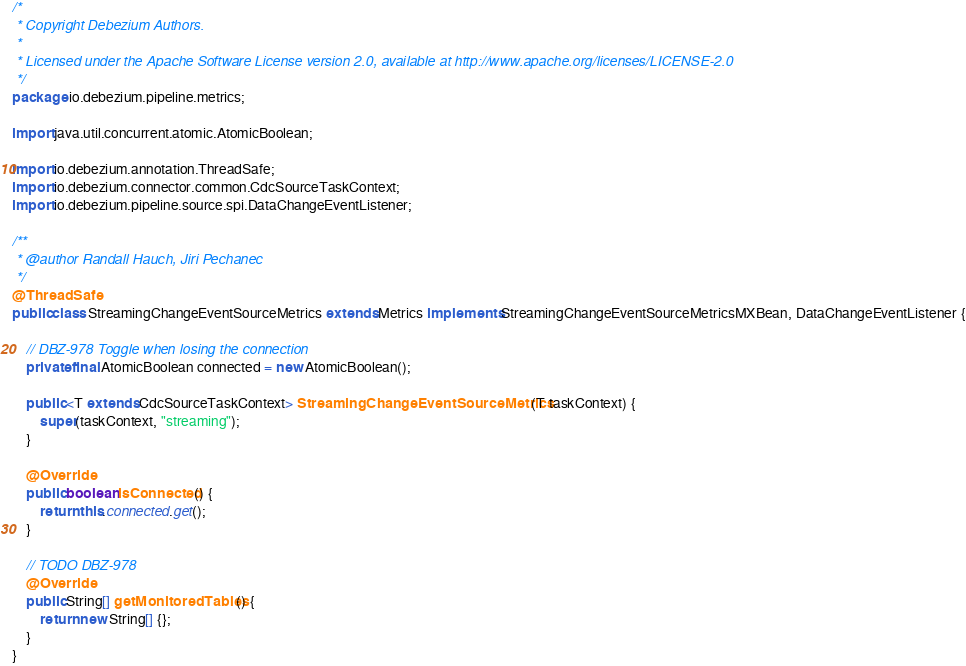<code> <loc_0><loc_0><loc_500><loc_500><_Java_>/*
 * Copyright Debezium Authors.
 *
 * Licensed under the Apache Software License version 2.0, available at http://www.apache.org/licenses/LICENSE-2.0
 */
package io.debezium.pipeline.metrics;

import java.util.concurrent.atomic.AtomicBoolean;

import io.debezium.annotation.ThreadSafe;
import io.debezium.connector.common.CdcSourceTaskContext;
import io.debezium.pipeline.source.spi.DataChangeEventListener;

/**
 * @author Randall Hauch, Jiri Pechanec
 */
@ThreadSafe
public class StreamingChangeEventSourceMetrics extends Metrics implements StreamingChangeEventSourceMetricsMXBean, DataChangeEventListener {

    // DBZ-978 Toggle when losing the connection
    private final AtomicBoolean connected = new AtomicBoolean();

    public <T extends CdcSourceTaskContext> StreamingChangeEventSourceMetrics(T taskContext) {
        super(taskContext, "streaming");
    }

    @Override
    public boolean isConnected() {
        return this.connected.get();
    }

    // TODO DBZ-978
    @Override
    public String[] getMonitoredTables() {
        return new String[] {};
    }
}
</code> 